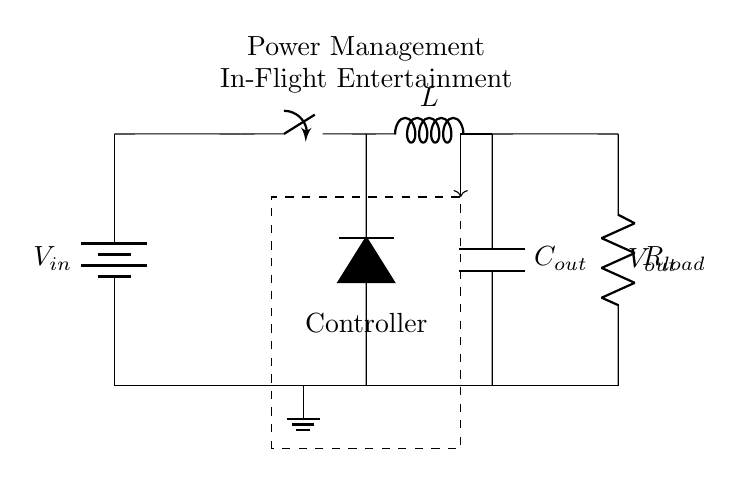What is the input component of this circuit? The input component is labeled as V_in, which indicates that it is a voltage source providing electrical energy to the circuit.
Answer: V_in What type of switch is used in the circuit? The switch in the circuit is a simple mechanical switch indicated by the visual representation. Its purpose is to control the flow of current within the circuit.
Answer: Switch What is the role of the inductor in this circuit? The inductor, labeled L, is used to store energy in the form of a magnetic field when current flows through it and helps regulate current in switching power supplies.
Answer: Store energy What is the output voltage labeled as? The output voltage is labeled as V_out, representing the voltage available for the load connected at the output side of the circuit.
Answer: V_out How does the feedback mechanism work in this circuit? The feedback is indicated by the arrow connecting the output capacitor to the controller, which adjusts the operation of the switching regulator based on the output voltage to maintain a stable output.
Answer: It stabilizes output What is connected to the output side of the circuit? The output side has a load connected, indicated by the resistor labeled R_load, which represents the consumption point of the power supplied by the regulator.
Answer: R_load Why is the controller important in this circuit? The controller is crucial as it manages the operation of the switch and ensures the output voltage remains stable, responding to changes in load and input voltage conditions.
Answer: Maintains output stability 